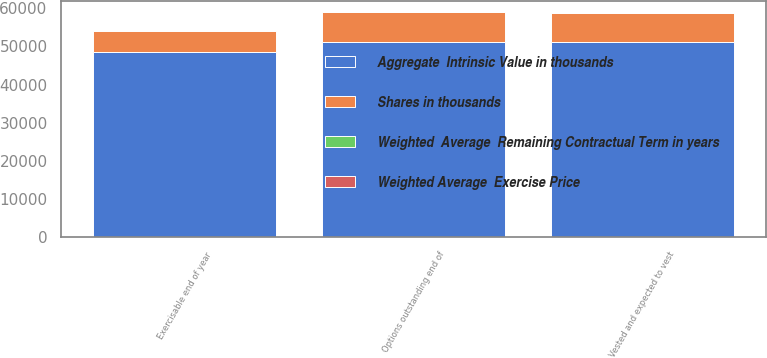Convert chart to OTSL. <chart><loc_0><loc_0><loc_500><loc_500><stacked_bar_chart><ecel><fcel>Options outstanding end of<fcel>Exercisable end of year<fcel>Vested and expected to vest<nl><fcel>Shares in thousands<fcel>7751<fcel>5537<fcel>7676<nl><fcel>Weighted  Average  Remaining Contractual Term in years<fcel>51.68<fcel>49.51<fcel>51.63<nl><fcel>Weighted Average  Exercise Price<fcel>5<fcel>2.4<fcel>5<nl><fcel>Aggregate  Intrinsic Value in thousands<fcel>51146<fcel>48564<fcel>51071<nl></chart> 